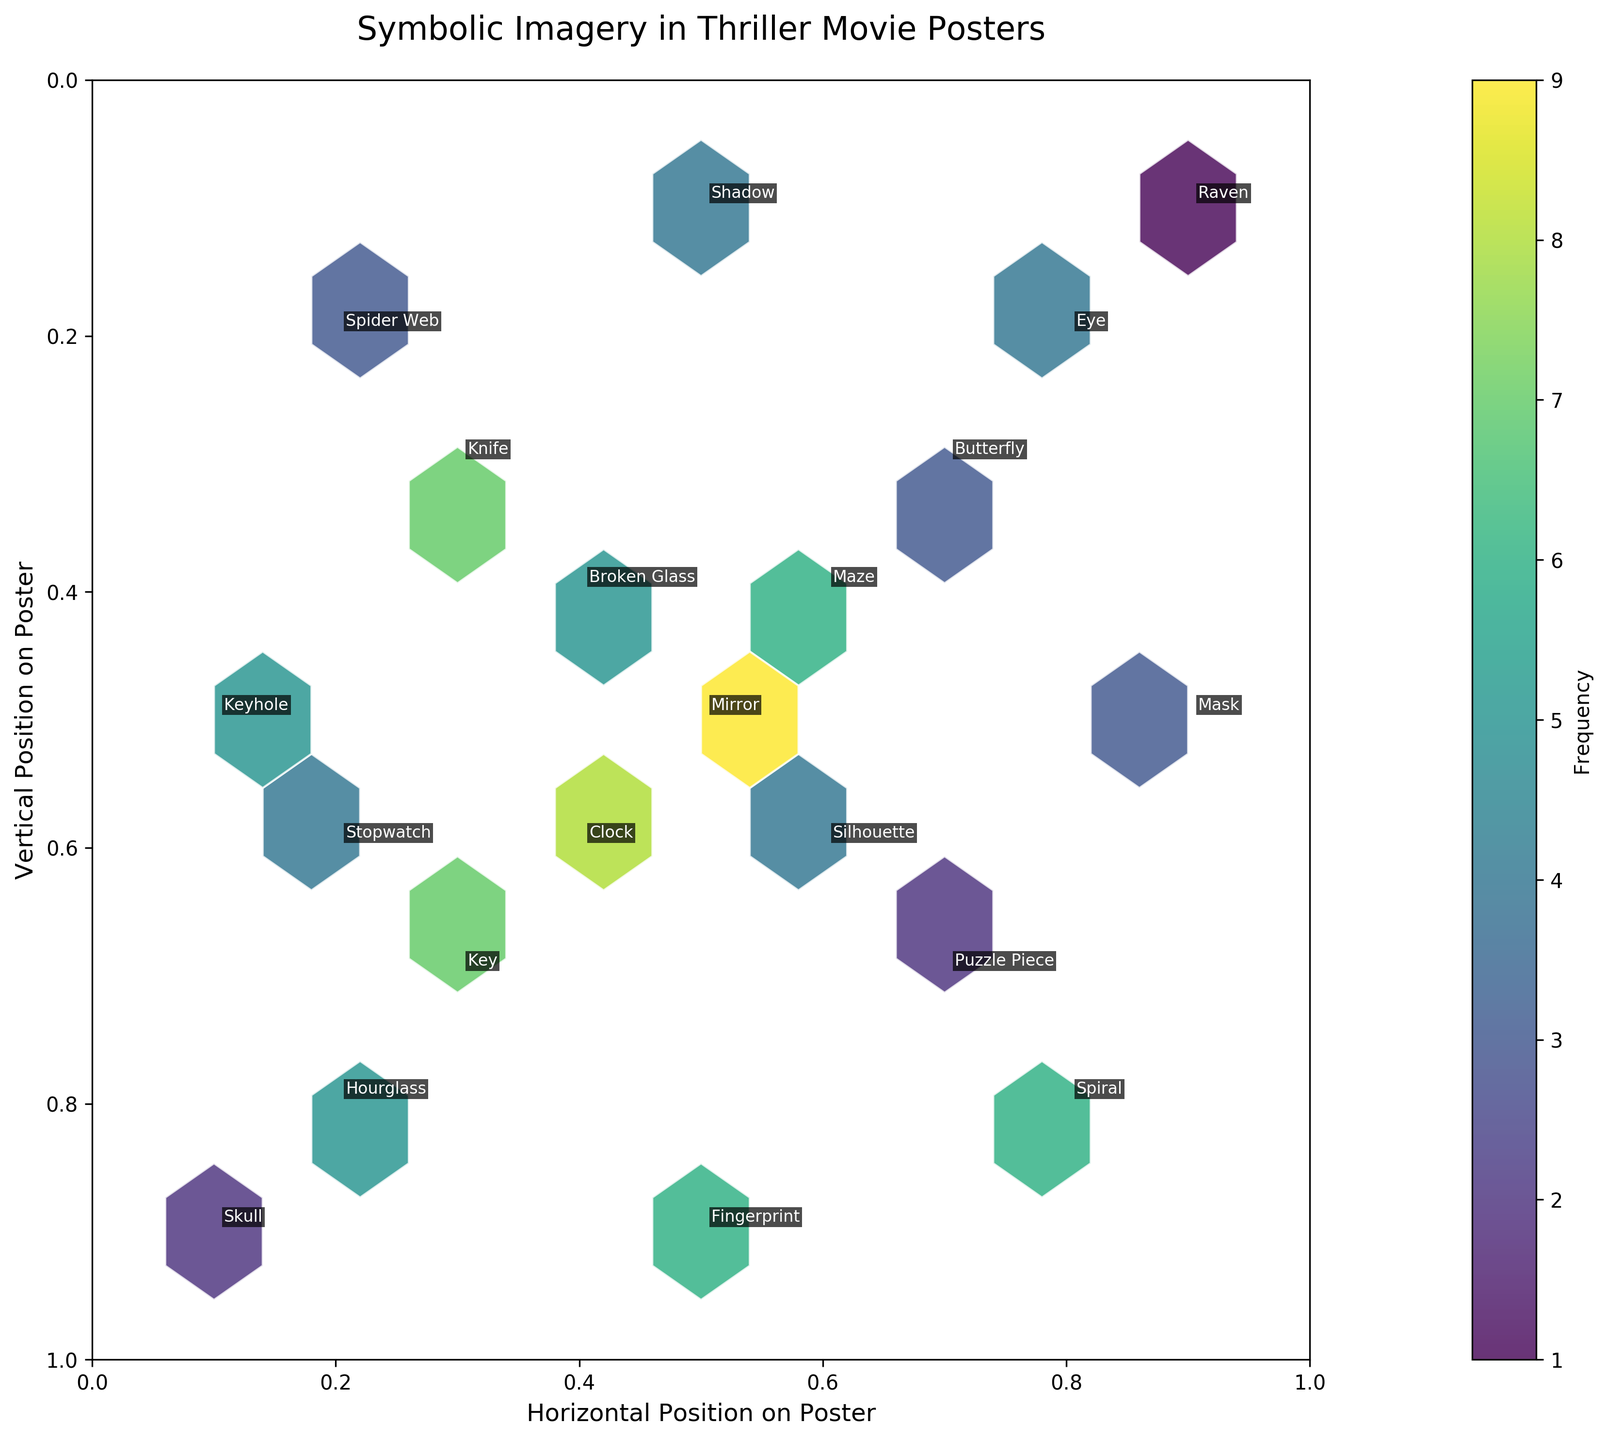What is the title of the plot? The title is found at the top of the plot.
Answer: Symbolic Imagery in Thriller Movie Posters What does the color bar represent in the plot? The color bar is labeled "Frequency" which indicates it represents the frequency of symbolic imagery occurrence.
Answer: Frequency Which symbol has the highest frequency? By examining the hexagons with the highest color intensity and their labeled annotations, we find that "Mirror" has the highest frequency of 9.
Answer: Mirror How many symbols are located in the central region of the poster (0.4 < x < 0.6 and 0.4 < y < 0.6)? We observe the coordinates and their respective annotations to count the symbols within the specified central area.
Answer: 4 (Clock, Broken Glass, Mirror, Silhouette) Is the symbol "Raven" found in the upper half or lower half of the poster? By analyzing the vertical position (y-coordinate) of "Raven" which is 0.1, we see it is in the lower half of the poster.
Answer: Lower half Which symbol is found closest to the top-left corner of the poster? Comparing the x and y values for each symbol, "Skull" with coordinates (0.1, 0.9) is nearest to the top-left corner.
Answer: Skull What's the average frequency of symbols located in the quadrants (0<x<=0.5, 0.5<y<=1) and (0.5<x<=1, 0.5<y<=1)? Identify the symbols in each quadrant, sum their frequencies and divide by the number of symbols to get the average. Quadrant 1: Hourglass (5), Key (7), Fingerprint (6). Quadrant 2: Spiral (6), Puzzle Piece (2). The average frequency for Quadrant 1 is (5+7+6)/3 = 6, and for Quadrant 2 is (6+2)/2 = 4.
Answer: 6 and 4 How does the frequency of symbols in the upper right quadrant (0.5 < x <= 1, 0.5 < y <= 1) compare to the lower left quadrant (0 < x <= 0.5, 0 < y <= 0.5)? Calculate the sum of frequencies in both quadrants and compare. Upper right: Silhouette (4), Spiral (6), Puzzle Piece (2). Lower left: Spider Web (3), Broken Glass (5), Knife (7). The frequency sum of upper right is 4+6+2=12, and lower left is 3+5+7=15.
Answer: Lower left is higher Which symbols are located in the bottom right area of the poster (0.5 < x <= 1 and 0 < y <= 0.5)? By checking the relevant coordinates in this region, we find the symbols "Butterfly" (0.7, 0.3), "Eye" (0.8, 0.2), "Shadow" (0.5, 0.1), and "Raven" (0.9, 0.1).
Answer: Butterfly, Eye, Shadow, Raven 